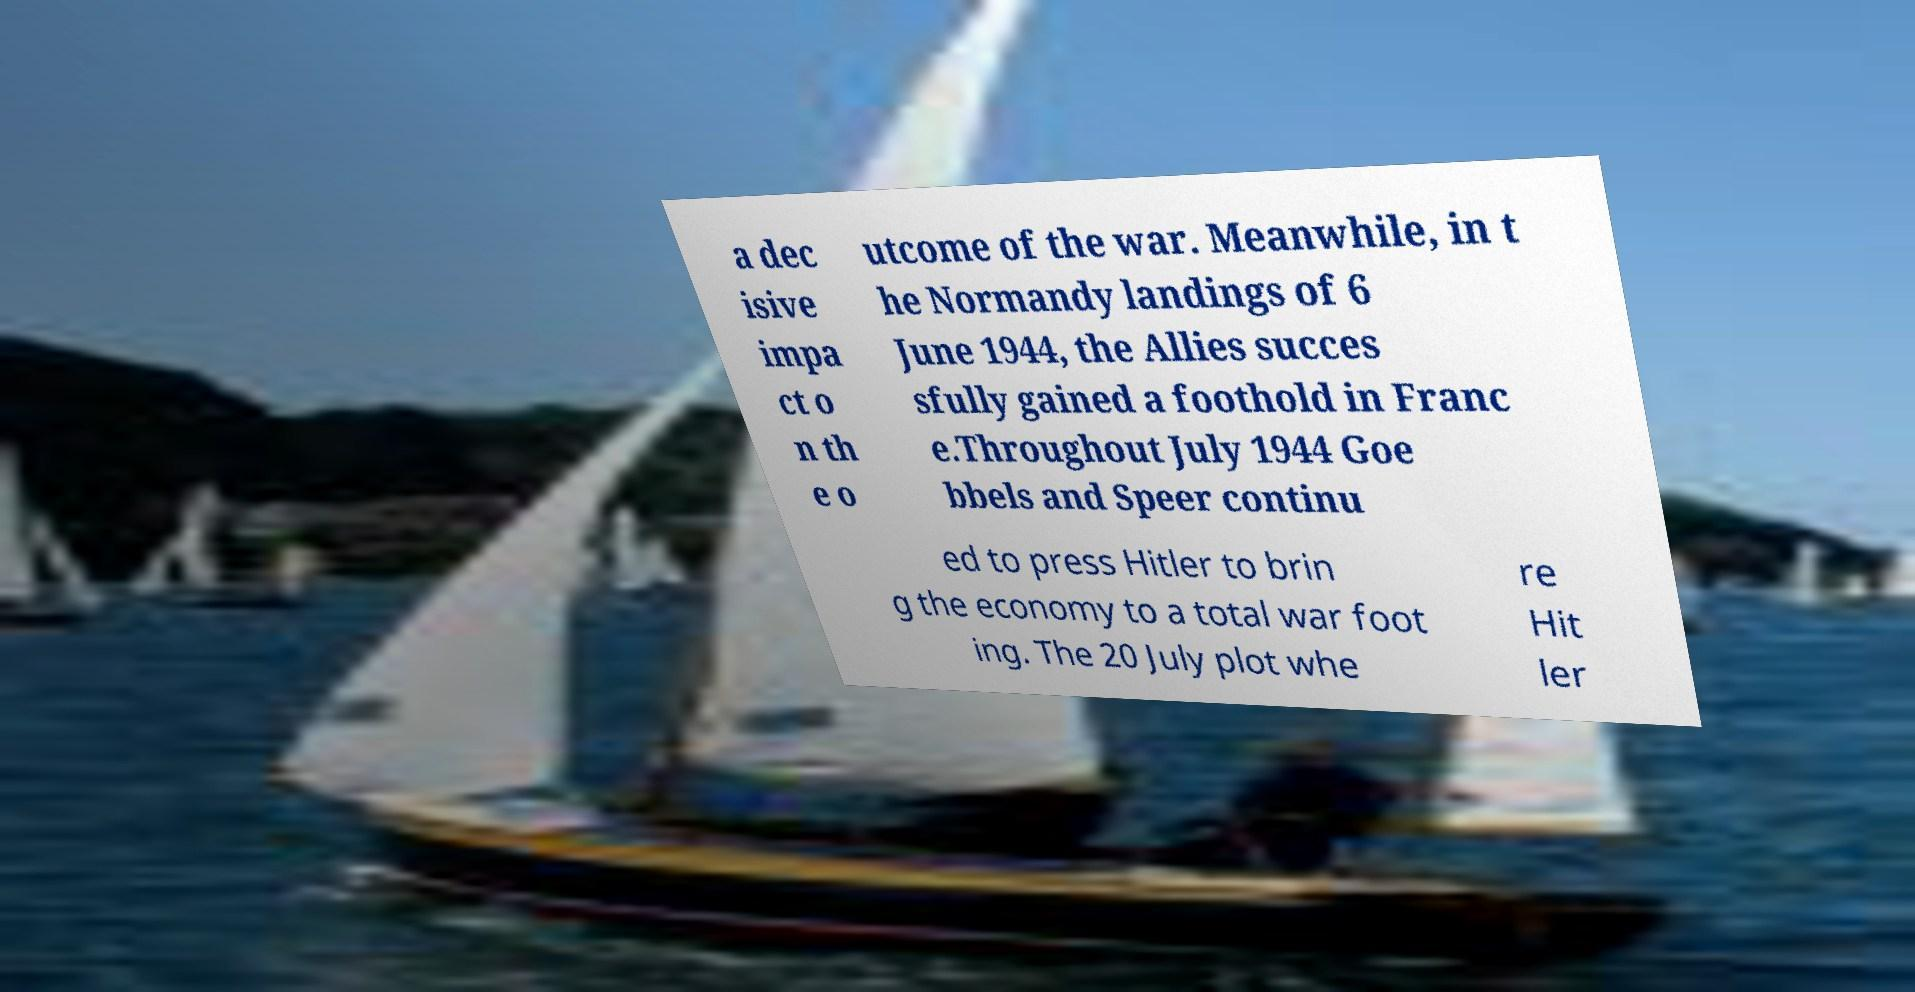For documentation purposes, I need the text within this image transcribed. Could you provide that? a dec isive impa ct o n th e o utcome of the war. Meanwhile, in t he Normandy landings of 6 June 1944, the Allies succes sfully gained a foothold in Franc e.Throughout July 1944 Goe bbels and Speer continu ed to press Hitler to brin g the economy to a total war foot ing. The 20 July plot whe re Hit ler 